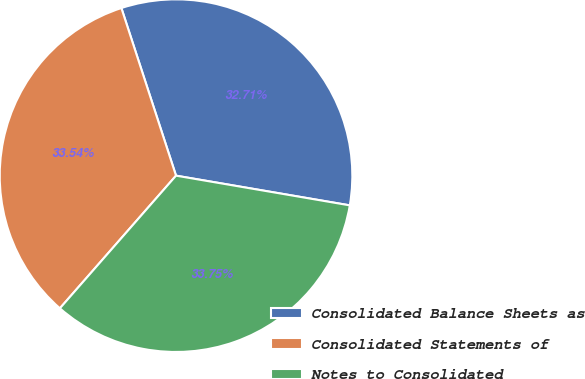<chart> <loc_0><loc_0><loc_500><loc_500><pie_chart><fcel>Consolidated Balance Sheets as<fcel>Consolidated Statements of<fcel>Notes to Consolidated<nl><fcel>32.71%<fcel>33.54%<fcel>33.75%<nl></chart> 